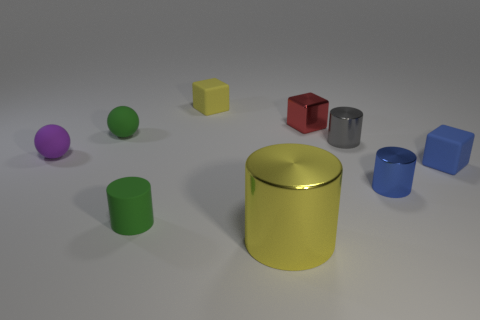Subtract all blue cylinders. How many cylinders are left? 3 Subtract 1 cubes. How many cubes are left? 2 Add 1 big brown things. How many objects exist? 10 Subtract all small rubber blocks. How many blocks are left? 1 Subtract all spheres. How many objects are left? 7 Subtract all tiny rubber things. Subtract all large rubber things. How many objects are left? 4 Add 8 red metal blocks. How many red metal blocks are left? 9 Add 7 blue matte blocks. How many blue matte blocks exist? 8 Subtract 1 gray cylinders. How many objects are left? 8 Subtract all green cubes. Subtract all yellow spheres. How many cubes are left? 3 